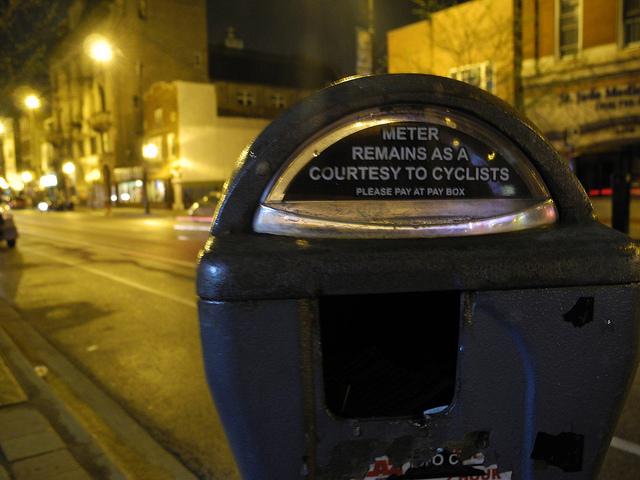How many coins does the machine need?
Write a very short answer. 0. What time of day is it?
Answer briefly. Night. What does the meter say?
Write a very short answer. Meter remains as courtesy to cyclists. Who does the meter remain as a courtesy to?
Be succinct. Cyclists. Where does the meter say to pay?
Quick response, please. Paybox. What are the meters used for?
Quick response, please. Parking. What is parked near the meter?
Quick response, please. Nothing. What would you have to do to legally park a car here?
Answer briefly. Pay. 